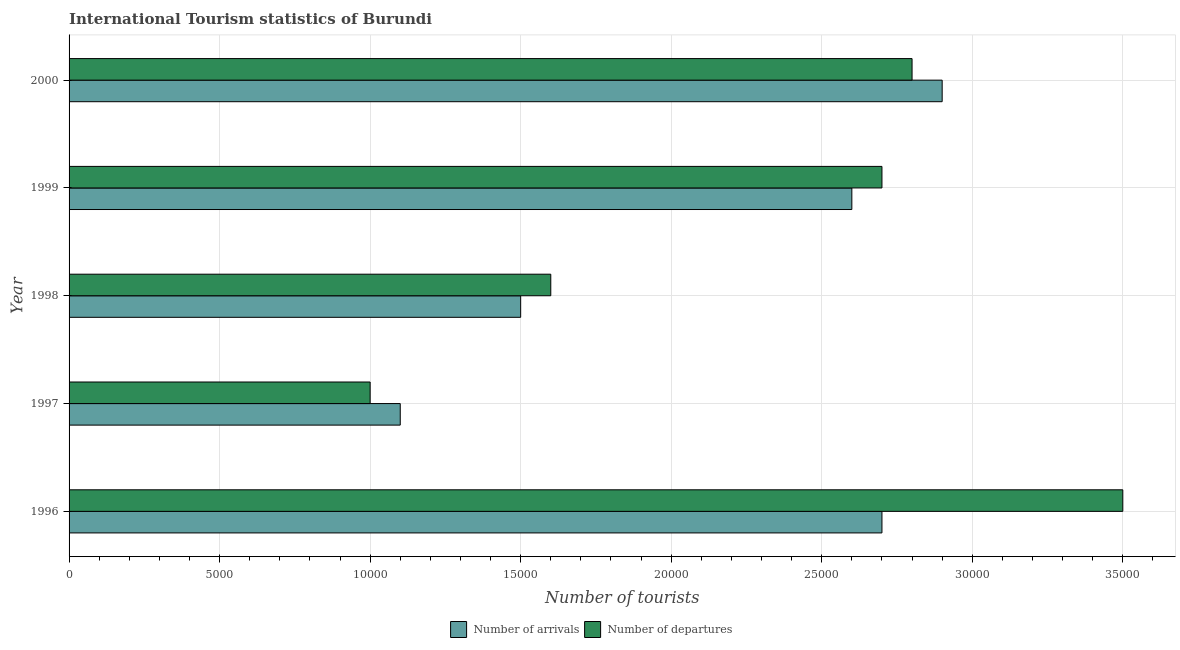How many groups of bars are there?
Give a very brief answer. 5. Are the number of bars on each tick of the Y-axis equal?
Keep it short and to the point. Yes. What is the label of the 4th group of bars from the top?
Ensure brevity in your answer.  1997. What is the number of tourist departures in 1997?
Give a very brief answer. 10000. Across all years, what is the maximum number of tourist arrivals?
Provide a short and direct response. 2.90e+04. Across all years, what is the minimum number of tourist departures?
Keep it short and to the point. 10000. In which year was the number of tourist departures minimum?
Ensure brevity in your answer.  1997. What is the total number of tourist arrivals in the graph?
Ensure brevity in your answer.  1.08e+05. What is the difference between the number of tourist departures in 1996 and that in 1998?
Your answer should be compact. 1.90e+04. What is the difference between the number of tourist departures in 2000 and the number of tourist arrivals in 1996?
Offer a very short reply. 1000. What is the average number of tourist arrivals per year?
Your answer should be very brief. 2.16e+04. In the year 1996, what is the difference between the number of tourist arrivals and number of tourist departures?
Your response must be concise. -8000. Is the difference between the number of tourist departures in 1996 and 1998 greater than the difference between the number of tourist arrivals in 1996 and 1998?
Keep it short and to the point. Yes. What is the difference between the highest and the lowest number of tourist departures?
Keep it short and to the point. 2.50e+04. In how many years, is the number of tourist arrivals greater than the average number of tourist arrivals taken over all years?
Offer a terse response. 3. What does the 2nd bar from the top in 1998 represents?
Your response must be concise. Number of arrivals. What does the 1st bar from the bottom in 1999 represents?
Offer a very short reply. Number of arrivals. How many bars are there?
Make the answer very short. 10. Are all the bars in the graph horizontal?
Offer a terse response. Yes. How many years are there in the graph?
Make the answer very short. 5. What is the difference between two consecutive major ticks on the X-axis?
Provide a succinct answer. 5000. Are the values on the major ticks of X-axis written in scientific E-notation?
Keep it short and to the point. No. Where does the legend appear in the graph?
Your answer should be very brief. Bottom center. What is the title of the graph?
Make the answer very short. International Tourism statistics of Burundi. What is the label or title of the X-axis?
Make the answer very short. Number of tourists. What is the label or title of the Y-axis?
Ensure brevity in your answer.  Year. What is the Number of tourists in Number of arrivals in 1996?
Keep it short and to the point. 2.70e+04. What is the Number of tourists of Number of departures in 1996?
Your response must be concise. 3.50e+04. What is the Number of tourists of Number of arrivals in 1997?
Provide a short and direct response. 1.10e+04. What is the Number of tourists of Number of arrivals in 1998?
Your answer should be compact. 1.50e+04. What is the Number of tourists of Number of departures in 1998?
Provide a succinct answer. 1.60e+04. What is the Number of tourists in Number of arrivals in 1999?
Make the answer very short. 2.60e+04. What is the Number of tourists of Number of departures in 1999?
Provide a succinct answer. 2.70e+04. What is the Number of tourists of Number of arrivals in 2000?
Make the answer very short. 2.90e+04. What is the Number of tourists of Number of departures in 2000?
Your answer should be very brief. 2.80e+04. Across all years, what is the maximum Number of tourists of Number of arrivals?
Ensure brevity in your answer.  2.90e+04. Across all years, what is the maximum Number of tourists in Number of departures?
Your answer should be compact. 3.50e+04. Across all years, what is the minimum Number of tourists in Number of arrivals?
Your answer should be compact. 1.10e+04. Across all years, what is the minimum Number of tourists of Number of departures?
Your response must be concise. 10000. What is the total Number of tourists in Number of arrivals in the graph?
Your answer should be very brief. 1.08e+05. What is the total Number of tourists of Number of departures in the graph?
Make the answer very short. 1.16e+05. What is the difference between the Number of tourists in Number of arrivals in 1996 and that in 1997?
Provide a succinct answer. 1.60e+04. What is the difference between the Number of tourists of Number of departures in 1996 and that in 1997?
Your answer should be compact. 2.50e+04. What is the difference between the Number of tourists in Number of arrivals in 1996 and that in 1998?
Your answer should be very brief. 1.20e+04. What is the difference between the Number of tourists of Number of departures in 1996 and that in 1998?
Your response must be concise. 1.90e+04. What is the difference between the Number of tourists of Number of arrivals in 1996 and that in 1999?
Your answer should be very brief. 1000. What is the difference between the Number of tourists of Number of departures in 1996 and that in 1999?
Ensure brevity in your answer.  8000. What is the difference between the Number of tourists in Number of arrivals in 1996 and that in 2000?
Provide a succinct answer. -2000. What is the difference between the Number of tourists in Number of departures in 1996 and that in 2000?
Offer a terse response. 7000. What is the difference between the Number of tourists in Number of arrivals in 1997 and that in 1998?
Your answer should be very brief. -4000. What is the difference between the Number of tourists of Number of departures in 1997 and that in 1998?
Provide a succinct answer. -6000. What is the difference between the Number of tourists in Number of arrivals in 1997 and that in 1999?
Make the answer very short. -1.50e+04. What is the difference between the Number of tourists of Number of departures in 1997 and that in 1999?
Offer a terse response. -1.70e+04. What is the difference between the Number of tourists of Number of arrivals in 1997 and that in 2000?
Give a very brief answer. -1.80e+04. What is the difference between the Number of tourists of Number of departures in 1997 and that in 2000?
Offer a terse response. -1.80e+04. What is the difference between the Number of tourists in Number of arrivals in 1998 and that in 1999?
Offer a very short reply. -1.10e+04. What is the difference between the Number of tourists in Number of departures in 1998 and that in 1999?
Provide a short and direct response. -1.10e+04. What is the difference between the Number of tourists in Number of arrivals in 1998 and that in 2000?
Ensure brevity in your answer.  -1.40e+04. What is the difference between the Number of tourists of Number of departures in 1998 and that in 2000?
Give a very brief answer. -1.20e+04. What is the difference between the Number of tourists in Number of arrivals in 1999 and that in 2000?
Make the answer very short. -3000. What is the difference between the Number of tourists of Number of departures in 1999 and that in 2000?
Give a very brief answer. -1000. What is the difference between the Number of tourists of Number of arrivals in 1996 and the Number of tourists of Number of departures in 1997?
Offer a very short reply. 1.70e+04. What is the difference between the Number of tourists of Number of arrivals in 1996 and the Number of tourists of Number of departures in 1998?
Ensure brevity in your answer.  1.10e+04. What is the difference between the Number of tourists of Number of arrivals in 1996 and the Number of tourists of Number of departures in 2000?
Your answer should be compact. -1000. What is the difference between the Number of tourists of Number of arrivals in 1997 and the Number of tourists of Number of departures in 1998?
Provide a short and direct response. -5000. What is the difference between the Number of tourists in Number of arrivals in 1997 and the Number of tourists in Number of departures in 1999?
Offer a terse response. -1.60e+04. What is the difference between the Number of tourists in Number of arrivals in 1997 and the Number of tourists in Number of departures in 2000?
Your response must be concise. -1.70e+04. What is the difference between the Number of tourists of Number of arrivals in 1998 and the Number of tourists of Number of departures in 1999?
Your answer should be very brief. -1.20e+04. What is the difference between the Number of tourists of Number of arrivals in 1998 and the Number of tourists of Number of departures in 2000?
Provide a short and direct response. -1.30e+04. What is the difference between the Number of tourists of Number of arrivals in 1999 and the Number of tourists of Number of departures in 2000?
Keep it short and to the point. -2000. What is the average Number of tourists in Number of arrivals per year?
Offer a very short reply. 2.16e+04. What is the average Number of tourists in Number of departures per year?
Make the answer very short. 2.32e+04. In the year 1996, what is the difference between the Number of tourists in Number of arrivals and Number of tourists in Number of departures?
Provide a succinct answer. -8000. In the year 1998, what is the difference between the Number of tourists in Number of arrivals and Number of tourists in Number of departures?
Your answer should be compact. -1000. In the year 1999, what is the difference between the Number of tourists in Number of arrivals and Number of tourists in Number of departures?
Make the answer very short. -1000. In the year 2000, what is the difference between the Number of tourists of Number of arrivals and Number of tourists of Number of departures?
Give a very brief answer. 1000. What is the ratio of the Number of tourists in Number of arrivals in 1996 to that in 1997?
Your answer should be compact. 2.45. What is the ratio of the Number of tourists in Number of departures in 1996 to that in 1997?
Offer a terse response. 3.5. What is the ratio of the Number of tourists of Number of arrivals in 1996 to that in 1998?
Offer a very short reply. 1.8. What is the ratio of the Number of tourists in Number of departures in 1996 to that in 1998?
Offer a very short reply. 2.19. What is the ratio of the Number of tourists in Number of arrivals in 1996 to that in 1999?
Provide a succinct answer. 1.04. What is the ratio of the Number of tourists of Number of departures in 1996 to that in 1999?
Ensure brevity in your answer.  1.3. What is the ratio of the Number of tourists in Number of departures in 1996 to that in 2000?
Your answer should be compact. 1.25. What is the ratio of the Number of tourists in Number of arrivals in 1997 to that in 1998?
Your answer should be very brief. 0.73. What is the ratio of the Number of tourists of Number of arrivals in 1997 to that in 1999?
Your response must be concise. 0.42. What is the ratio of the Number of tourists of Number of departures in 1997 to that in 1999?
Ensure brevity in your answer.  0.37. What is the ratio of the Number of tourists of Number of arrivals in 1997 to that in 2000?
Make the answer very short. 0.38. What is the ratio of the Number of tourists of Number of departures in 1997 to that in 2000?
Your answer should be very brief. 0.36. What is the ratio of the Number of tourists of Number of arrivals in 1998 to that in 1999?
Make the answer very short. 0.58. What is the ratio of the Number of tourists of Number of departures in 1998 to that in 1999?
Your response must be concise. 0.59. What is the ratio of the Number of tourists in Number of arrivals in 1998 to that in 2000?
Give a very brief answer. 0.52. What is the ratio of the Number of tourists of Number of arrivals in 1999 to that in 2000?
Your answer should be very brief. 0.9. What is the ratio of the Number of tourists of Number of departures in 1999 to that in 2000?
Your answer should be compact. 0.96. What is the difference between the highest and the second highest Number of tourists in Number of departures?
Offer a terse response. 7000. What is the difference between the highest and the lowest Number of tourists in Number of arrivals?
Offer a very short reply. 1.80e+04. What is the difference between the highest and the lowest Number of tourists of Number of departures?
Your answer should be very brief. 2.50e+04. 